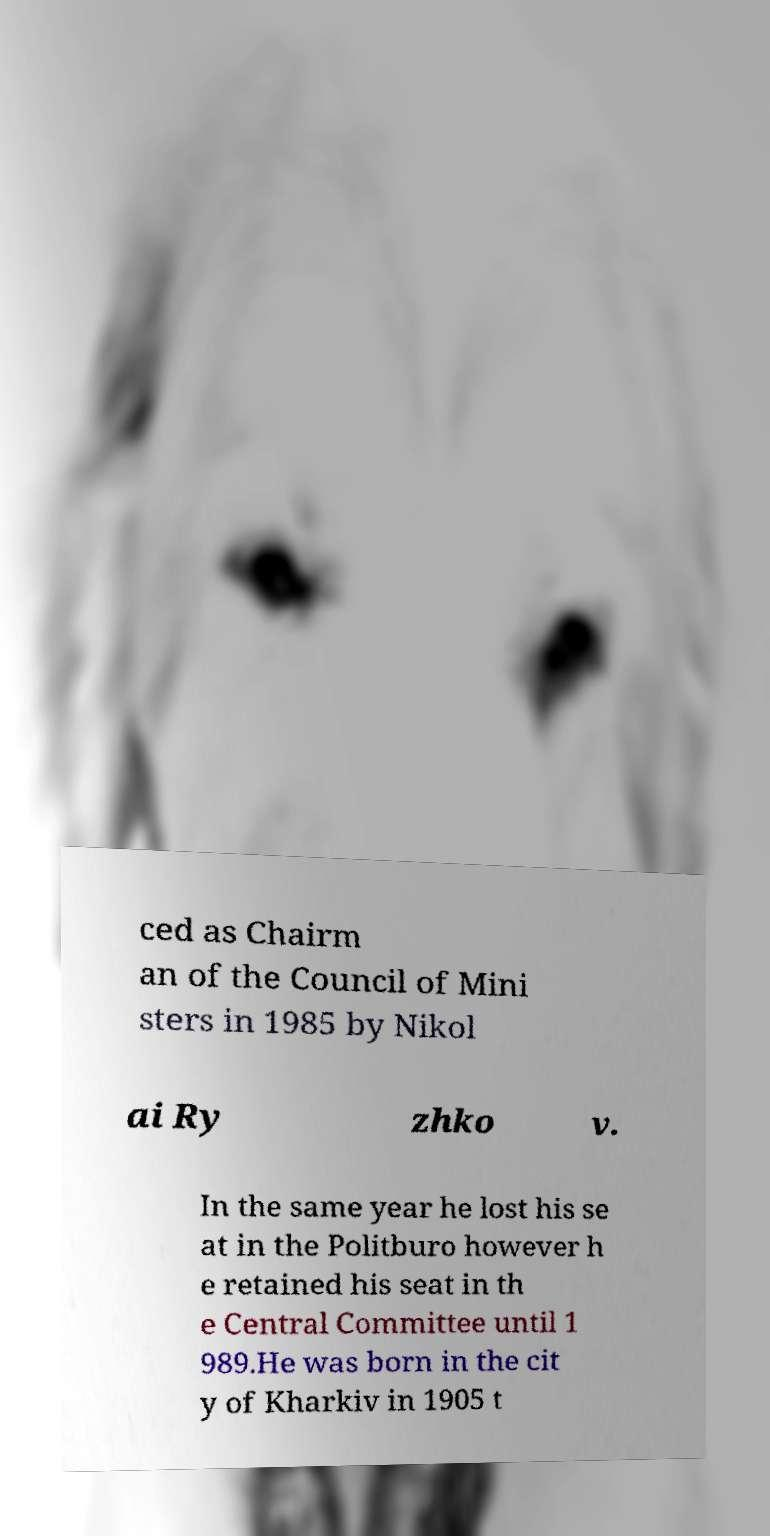Could you assist in decoding the text presented in this image and type it out clearly? ced as Chairm an of the Council of Mini sters in 1985 by Nikol ai Ry zhko v. In the same year he lost his se at in the Politburo however h e retained his seat in th e Central Committee until 1 989.He was born in the cit y of Kharkiv in 1905 t 